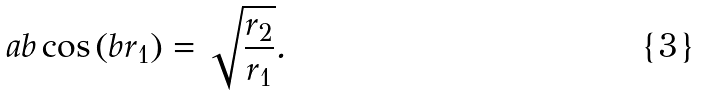Convert formula to latex. <formula><loc_0><loc_0><loc_500><loc_500>a b \cos \left ( b r _ { 1 } \right ) = \sqrt { \frac { r _ { 2 } } { r _ { 1 } } } .</formula> 